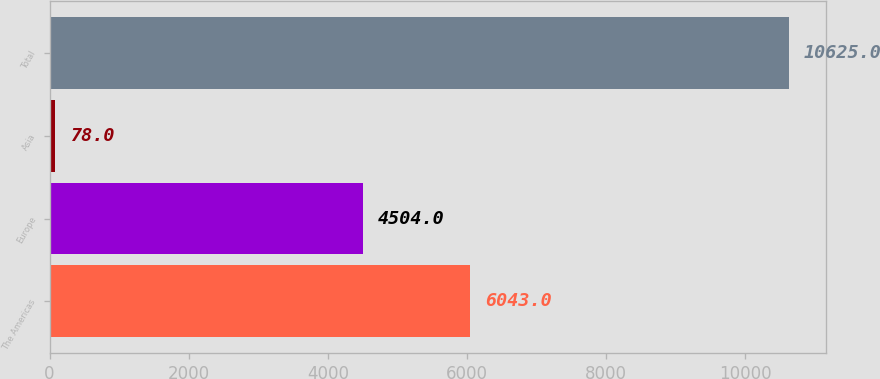<chart> <loc_0><loc_0><loc_500><loc_500><bar_chart><fcel>The Americas<fcel>Europe<fcel>Asia<fcel>Total<nl><fcel>6043<fcel>4504<fcel>78<fcel>10625<nl></chart> 